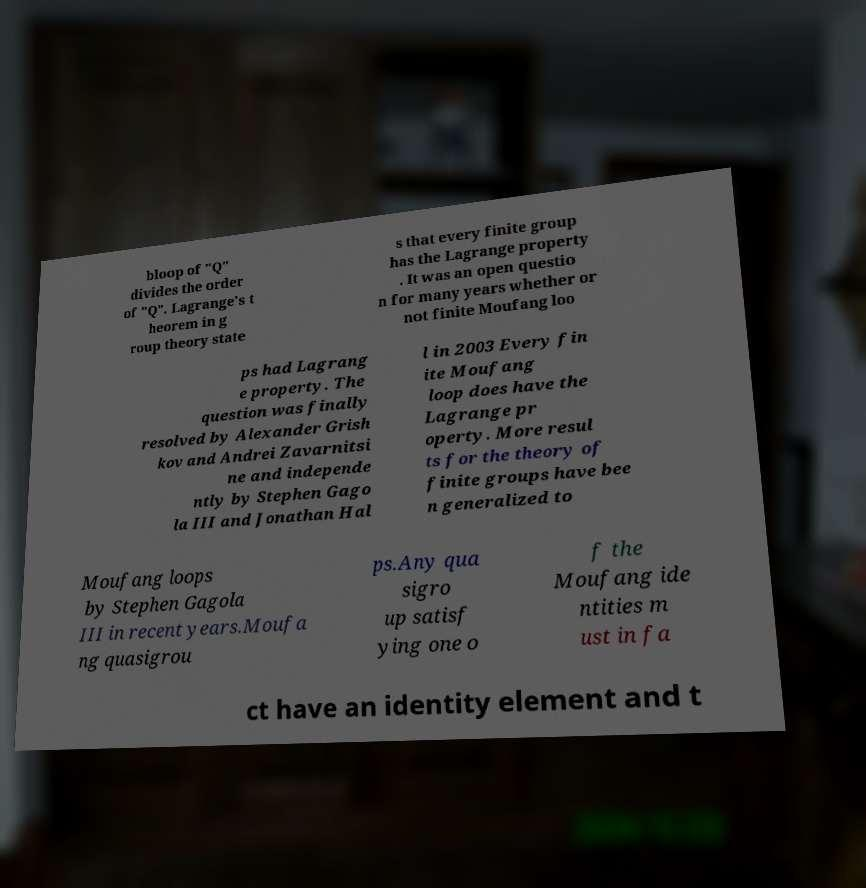Please identify and transcribe the text found in this image. bloop of "Q" divides the order of "Q". Lagrange's t heorem in g roup theory state s that every finite group has the Lagrange property . It was an open questio n for many years whether or not finite Moufang loo ps had Lagrang e property. The question was finally resolved by Alexander Grish kov and Andrei Zavarnitsi ne and independe ntly by Stephen Gago la III and Jonathan Hal l in 2003 Every fin ite Moufang loop does have the Lagrange pr operty. More resul ts for the theory of finite groups have bee n generalized to Moufang loops by Stephen Gagola III in recent years.Moufa ng quasigrou ps.Any qua sigro up satisf ying one o f the Moufang ide ntities m ust in fa ct have an identity element and t 